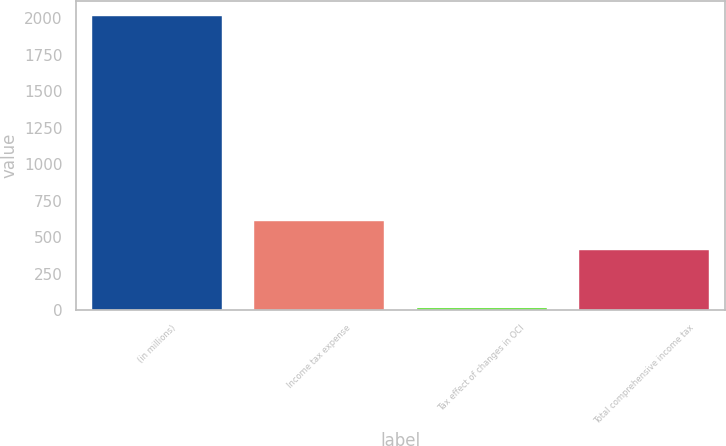Convert chart to OTSL. <chart><loc_0><loc_0><loc_500><loc_500><bar_chart><fcel>(in millions)<fcel>Income tax expense<fcel>Tax effect of changes in OCI<fcel>Total comprehensive income tax<nl><fcel>2015<fcel>611.3<fcel>12<fcel>411<nl></chart> 